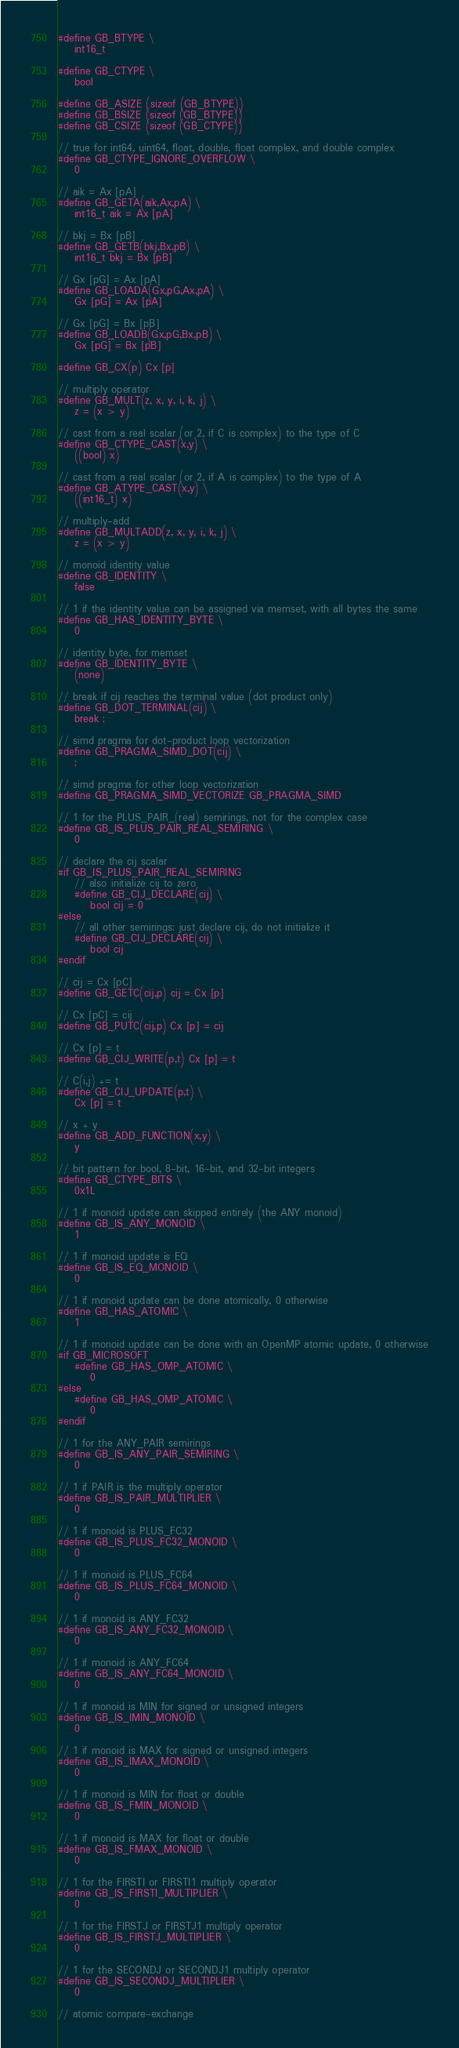<code> <loc_0><loc_0><loc_500><loc_500><_C_>#define GB_BTYPE \
    int16_t

#define GB_CTYPE \
    bool

#define GB_ASIZE (sizeof (GB_BTYPE))
#define GB_BSIZE (sizeof (GB_BTYPE))
#define GB_CSIZE (sizeof (GB_CTYPE))

// true for int64, uint64, float, double, float complex, and double complex 
#define GB_CTYPE_IGNORE_OVERFLOW \
    0

// aik = Ax [pA]
#define GB_GETA(aik,Ax,pA) \
    int16_t aik = Ax [pA]

// bkj = Bx [pB]
#define GB_GETB(bkj,Bx,pB) \
    int16_t bkj = Bx [pB]

// Gx [pG] = Ax [pA]
#define GB_LOADA(Gx,pG,Ax,pA) \
    Gx [pG] = Ax [pA]

// Gx [pG] = Bx [pB]
#define GB_LOADB(Gx,pG,Bx,pB) \
    Gx [pG] = Bx [pB]

#define GB_CX(p) Cx [p]

// multiply operator
#define GB_MULT(z, x, y, i, k, j) \
    z = (x > y)

// cast from a real scalar (or 2, if C is complex) to the type of C
#define GB_CTYPE_CAST(x,y) \
    ((bool) x)

// cast from a real scalar (or 2, if A is complex) to the type of A
#define GB_ATYPE_CAST(x,y) \
    ((int16_t) x)

// multiply-add
#define GB_MULTADD(z, x, y, i, k, j) \
    z = (x > y)

// monoid identity value
#define GB_IDENTITY \
    false

// 1 if the identity value can be assigned via memset, with all bytes the same
#define GB_HAS_IDENTITY_BYTE \
    0

// identity byte, for memset
#define GB_IDENTITY_BYTE \
    (none)

// break if cij reaches the terminal value (dot product only)
#define GB_DOT_TERMINAL(cij) \
    break ;

// simd pragma for dot-product loop vectorization
#define GB_PRAGMA_SIMD_DOT(cij) \
    ;

// simd pragma for other loop vectorization
#define GB_PRAGMA_SIMD_VECTORIZE GB_PRAGMA_SIMD

// 1 for the PLUS_PAIR_(real) semirings, not for the complex case
#define GB_IS_PLUS_PAIR_REAL_SEMIRING \
    0

// declare the cij scalar
#if GB_IS_PLUS_PAIR_REAL_SEMIRING
    // also initialize cij to zero
    #define GB_CIJ_DECLARE(cij) \
        bool cij = 0
#else
    // all other semirings: just declare cij, do not initialize it
    #define GB_CIJ_DECLARE(cij) \
        bool cij
#endif

// cij = Cx [pC]
#define GB_GETC(cij,p) cij = Cx [p]

// Cx [pC] = cij
#define GB_PUTC(cij,p) Cx [p] = cij

// Cx [p] = t
#define GB_CIJ_WRITE(p,t) Cx [p] = t

// C(i,j) += t
#define GB_CIJ_UPDATE(p,t) \
    Cx [p] = t

// x + y
#define GB_ADD_FUNCTION(x,y) \
    y

// bit pattern for bool, 8-bit, 16-bit, and 32-bit integers
#define GB_CTYPE_BITS \
    0x1L

// 1 if monoid update can skipped entirely (the ANY monoid)
#define GB_IS_ANY_MONOID \
    1

// 1 if monoid update is EQ
#define GB_IS_EQ_MONOID \
    0

// 1 if monoid update can be done atomically, 0 otherwise
#define GB_HAS_ATOMIC \
    1

// 1 if monoid update can be done with an OpenMP atomic update, 0 otherwise
#if GB_MICROSOFT
    #define GB_HAS_OMP_ATOMIC \
        0
#else
    #define GB_HAS_OMP_ATOMIC \
        0
#endif

// 1 for the ANY_PAIR semirings
#define GB_IS_ANY_PAIR_SEMIRING \
    0

// 1 if PAIR is the multiply operator 
#define GB_IS_PAIR_MULTIPLIER \
    0

// 1 if monoid is PLUS_FC32
#define GB_IS_PLUS_FC32_MONOID \
    0

// 1 if monoid is PLUS_FC64
#define GB_IS_PLUS_FC64_MONOID \
    0

// 1 if monoid is ANY_FC32
#define GB_IS_ANY_FC32_MONOID \
    0

// 1 if monoid is ANY_FC64
#define GB_IS_ANY_FC64_MONOID \
    0

// 1 if monoid is MIN for signed or unsigned integers
#define GB_IS_IMIN_MONOID \
    0

// 1 if monoid is MAX for signed or unsigned integers
#define GB_IS_IMAX_MONOID \
    0

// 1 if monoid is MIN for float or double
#define GB_IS_FMIN_MONOID \
    0

// 1 if monoid is MAX for float or double
#define GB_IS_FMAX_MONOID \
    0

// 1 for the FIRSTI or FIRSTI1 multiply operator
#define GB_IS_FIRSTI_MULTIPLIER \
    0

// 1 for the FIRSTJ or FIRSTJ1 multiply operator
#define GB_IS_FIRSTJ_MULTIPLIER \
    0

// 1 for the SECONDJ or SECONDJ1 multiply operator
#define GB_IS_SECONDJ_MULTIPLIER \
    0

// atomic compare-exchange</code> 